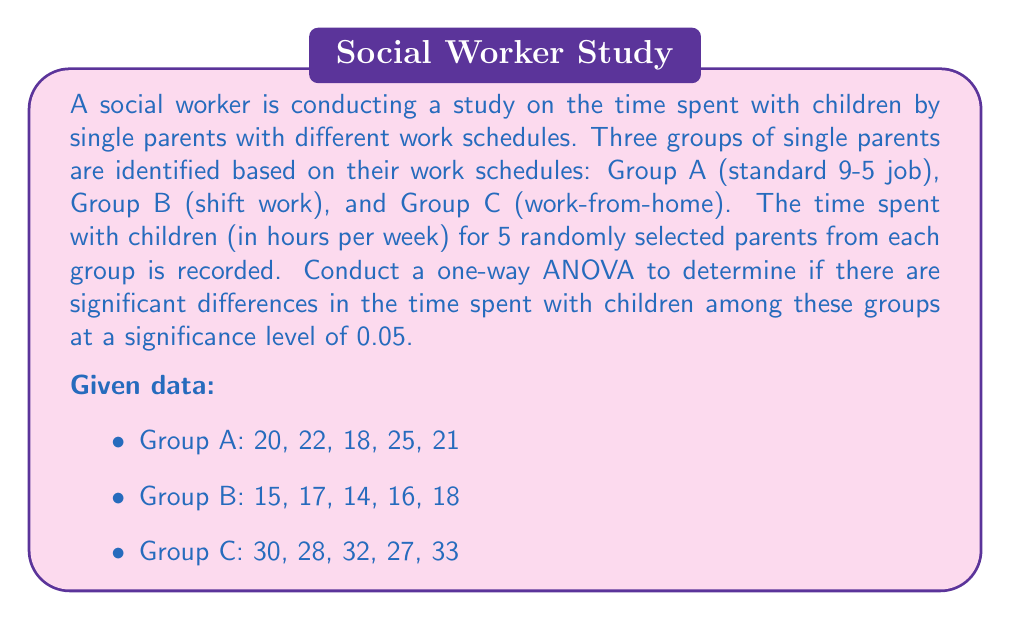Can you solve this math problem? To conduct a one-way ANOVA, we need to follow these steps:

1. Calculate the sum of squares between groups (SSB), sum of squares within groups (SSW), and total sum of squares (SST).

2. Calculate the degrees of freedom for between groups (dfB), within groups (dfW), and total (dfT).

3. Calculate the mean square between groups (MSB) and mean square within groups (MSW).

4. Calculate the F-statistic.

5. Compare the F-statistic with the critical F-value to make a decision.

Step 1: Calculate sums of squares

First, we need to calculate the grand mean:
$$\bar{X} = \frac{20+22+18+25+21+15+17+14+16+18+30+28+32+27+33}{15} = 22.4$$

Now, we can calculate SSB, SSW, and SST:

SSB = $n\sum_{i=1}^k(\bar{X_i} - \bar{X})^2$
where $n$ is the number of observations in each group, $k$ is the number of groups, $\bar{X_i}$ is the mean of each group, and $\bar{X}$ is the grand mean.

$\bar{X_A} = 21.2$, $\bar{X_B} = 16$, $\bar{X_C} = 30$

SSB = $5[(21.2 - 22.4)^2 + (16 - 22.4)^2 + (30 - 22.4)^2] = 504.8$

SSW = $\sum_{i=1}^k\sum_{j=1}^n(X_{ij} - \bar{X_i})^2$

SSW = $(20-21.2)^2 + (22-21.2)^2 + (18-21.2)^2 + (25-21.2)^2 + (21-21.2)^2 +$
      $(15-16)^2 + (17-16)^2 + (14-16)^2 + (16-16)^2 + (18-16)^2 +$
      $(30-30)^2 + (28-30)^2 + (32-30)^2 + (27-30)^2 + (33-30)^2$
    = $76.8$

SST = SSB + SSW = 504.8 + 76.8 = 581.6

Step 2: Calculate degrees of freedom

dfB = k - 1 = 3 - 1 = 2
dfW = N - k = 15 - 3 = 12
dfT = N - 1 = 15 - 1 = 14

Step 3: Calculate mean squares

MSB = SSB / dfB = 504.8 / 2 = 252.4
MSW = SSW / dfW = 76.8 / 12 = 6.4

Step 4: Calculate F-statistic

F = MSB / MSW = 252.4 / 6.4 = 39.4375

Step 5: Compare F-statistic with critical F-value

At α = 0.05, with dfB = 2 and dfW = 12, the critical F-value is approximately 3.89 (from F-distribution table).

Since the calculated F-statistic (39.4375) is greater than the critical F-value (3.89), we reject the null hypothesis.
Answer: The one-way ANOVA results show a significant difference in time spent with children among single parents with varying work schedules (F(2, 12) = 39.4375, p < 0.05). We reject the null hypothesis and conclude that there are significant differences in the time spent with children among the three groups of single parents with different work schedules. 